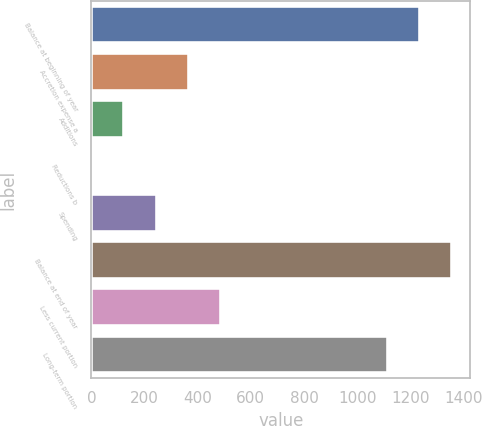Convert chart to OTSL. <chart><loc_0><loc_0><loc_500><loc_500><bar_chart><fcel>Balance at beginning of year<fcel>Accretion expense a<fcel>Additions<fcel>Reductions b<fcel>Spending<fcel>Balance at end of year<fcel>Less current portion<fcel>Long-term portion<nl><fcel>1236.2<fcel>366.6<fcel>124.2<fcel>3<fcel>245.4<fcel>1357.4<fcel>487.8<fcel>1115<nl></chart> 